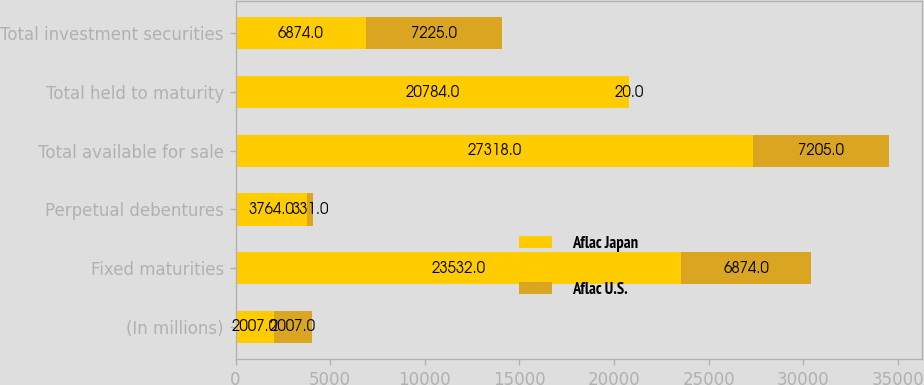Convert chart to OTSL. <chart><loc_0><loc_0><loc_500><loc_500><stacked_bar_chart><ecel><fcel>(In millions)<fcel>Fixed maturities<fcel>Perpetual debentures<fcel>Total available for sale<fcel>Total held to maturity<fcel>Total investment securities<nl><fcel>Aflac Japan<fcel>2007<fcel>23532<fcel>3764<fcel>27318<fcel>20784<fcel>6874<nl><fcel>Aflac U.S.<fcel>2007<fcel>6874<fcel>331<fcel>7205<fcel>20<fcel>7225<nl></chart> 